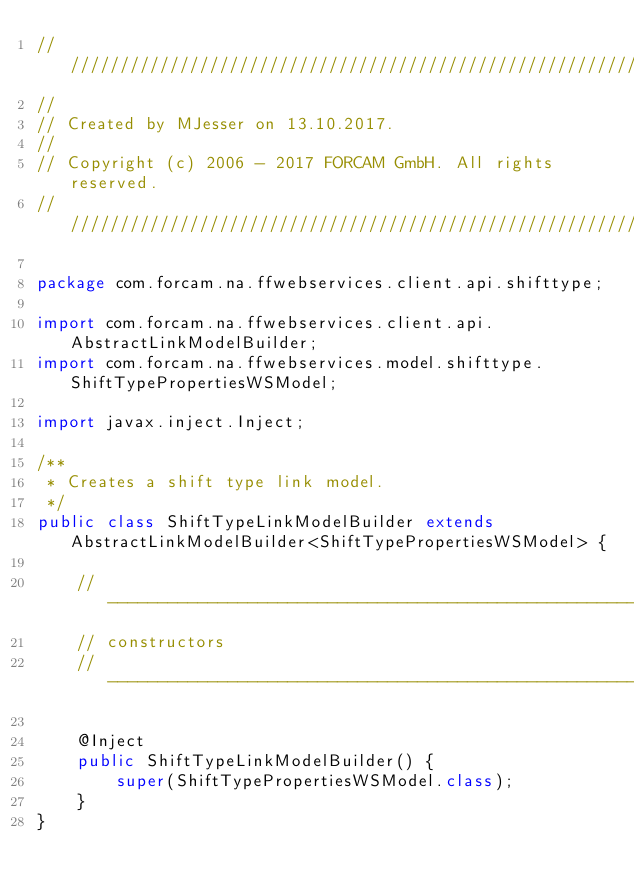<code> <loc_0><loc_0><loc_500><loc_500><_Java_>////////////////////////////////////////////////////////////////////////////////
//
// Created by MJesser on 13.10.2017.
//
// Copyright (c) 2006 - 2017 FORCAM GmbH. All rights reserved.
////////////////////////////////////////////////////////////////////////////////

package com.forcam.na.ffwebservices.client.api.shifttype;

import com.forcam.na.ffwebservices.client.api.AbstractLinkModelBuilder;
import com.forcam.na.ffwebservices.model.shifttype.ShiftTypePropertiesWSModel;

import javax.inject.Inject;

/**
 * Creates a shift type link model.
 */
public class ShiftTypeLinkModelBuilder extends AbstractLinkModelBuilder<ShiftTypePropertiesWSModel> {

    // ----------------------------------------------------------------------
    // constructors
    // ----------------------------------------------------------------------

    @Inject
    public ShiftTypeLinkModelBuilder() {
        super(ShiftTypePropertiesWSModel.class);
    }
}</code> 